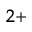<formula> <loc_0><loc_0><loc_500><loc_500>^ { 2 + }</formula> 